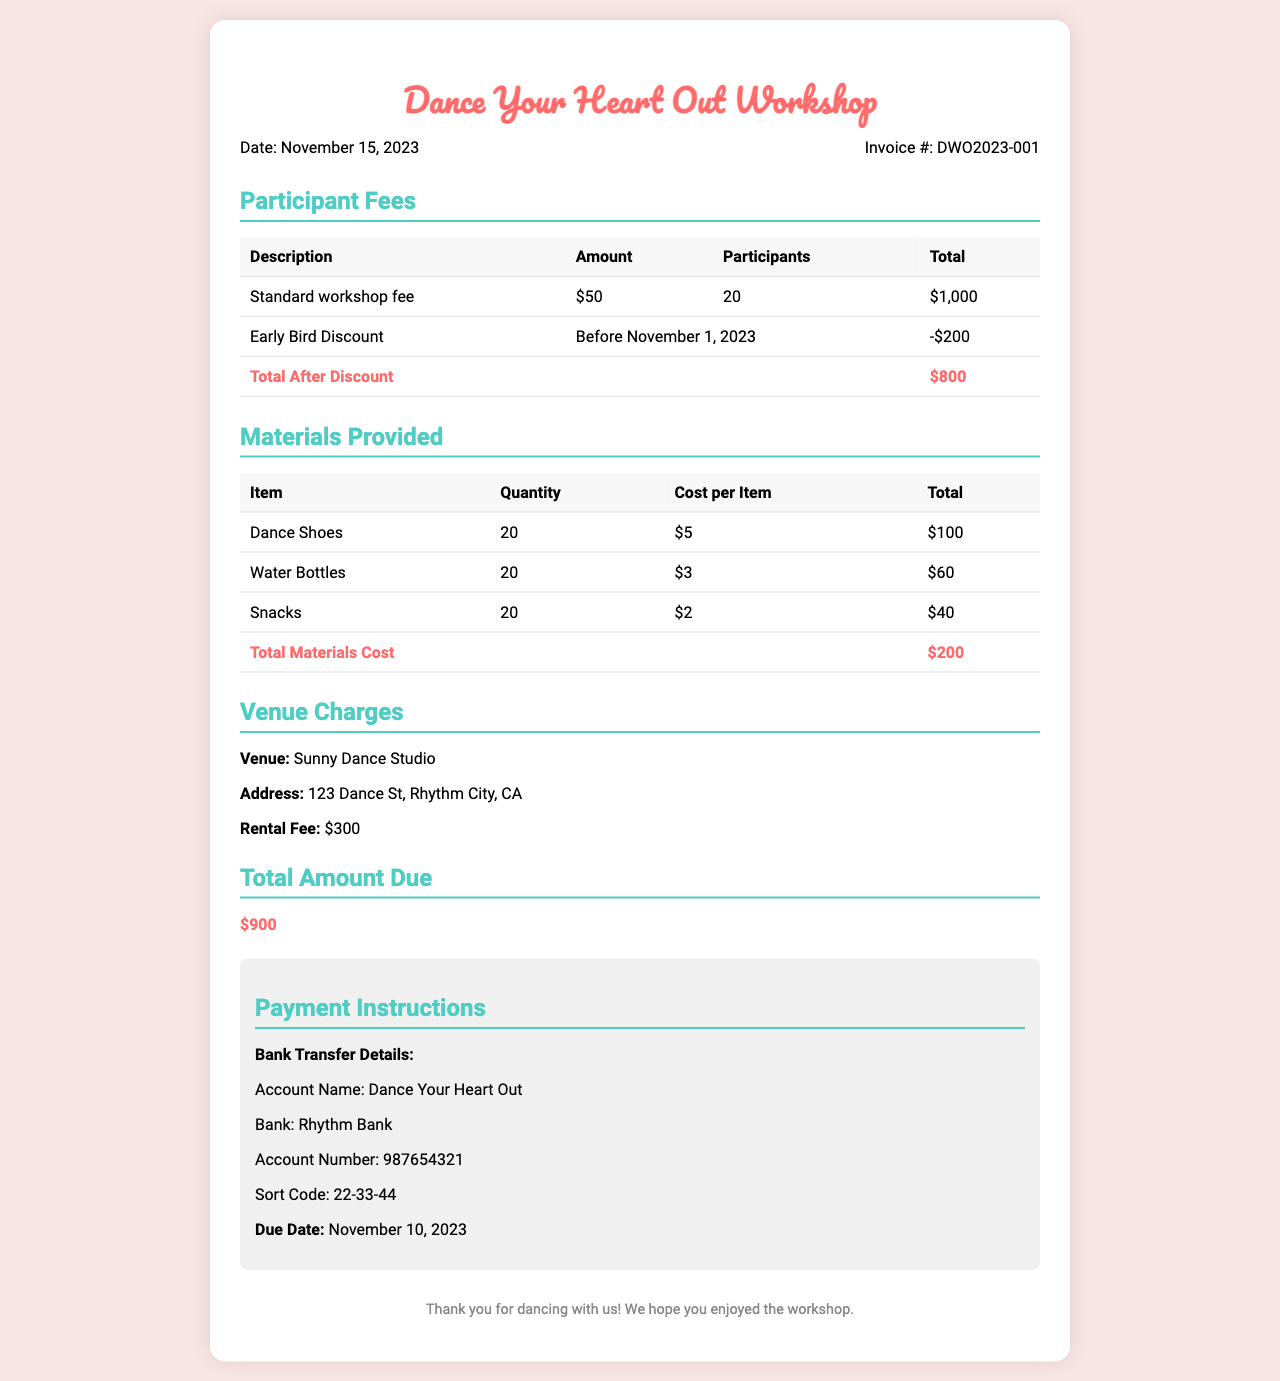what is the invoice date? The invoice date is mentioned prominently in the invoice details section, which is November 15, 2023.
Answer: November 15, 2023 how many participants attended the workshop? The total number of participants is listed under participant fees as 20.
Answer: 20 what is the total amount due? The total amount due is stated in the total amount due section, which summarizes all costs.
Answer: $900 what is the venue address? The address of the venue is provided under the venue charges section.
Answer: 123 Dance St, Rhythm City, CA how much was the early bird discount? The early bird discount is specified in the participant fees section as being $200.
Answer: -$200 what is the rental fee for the venue? The rental fee is detailed under the venue charges section of the invoice.
Answer: $300 how much did the dance shoes cost in total? The total cost for dance shoes is calculated by multiplying the quantity by the cost per item in the materials provided section, which is $5 per item for 20 items.
Answer: $100 what type of workshop is this invoice for? The title at the top of the invoice indicates that this is for a workshop named "Dance Your Heart Out."
Answer: Dance Your Heart Out Workshop what are the payment instructions mentioned? The payment instructions section provides specific details for bank transfer, including account name and number.
Answer: Account Name: Dance Your Heart Out, Account Number: 987654321 